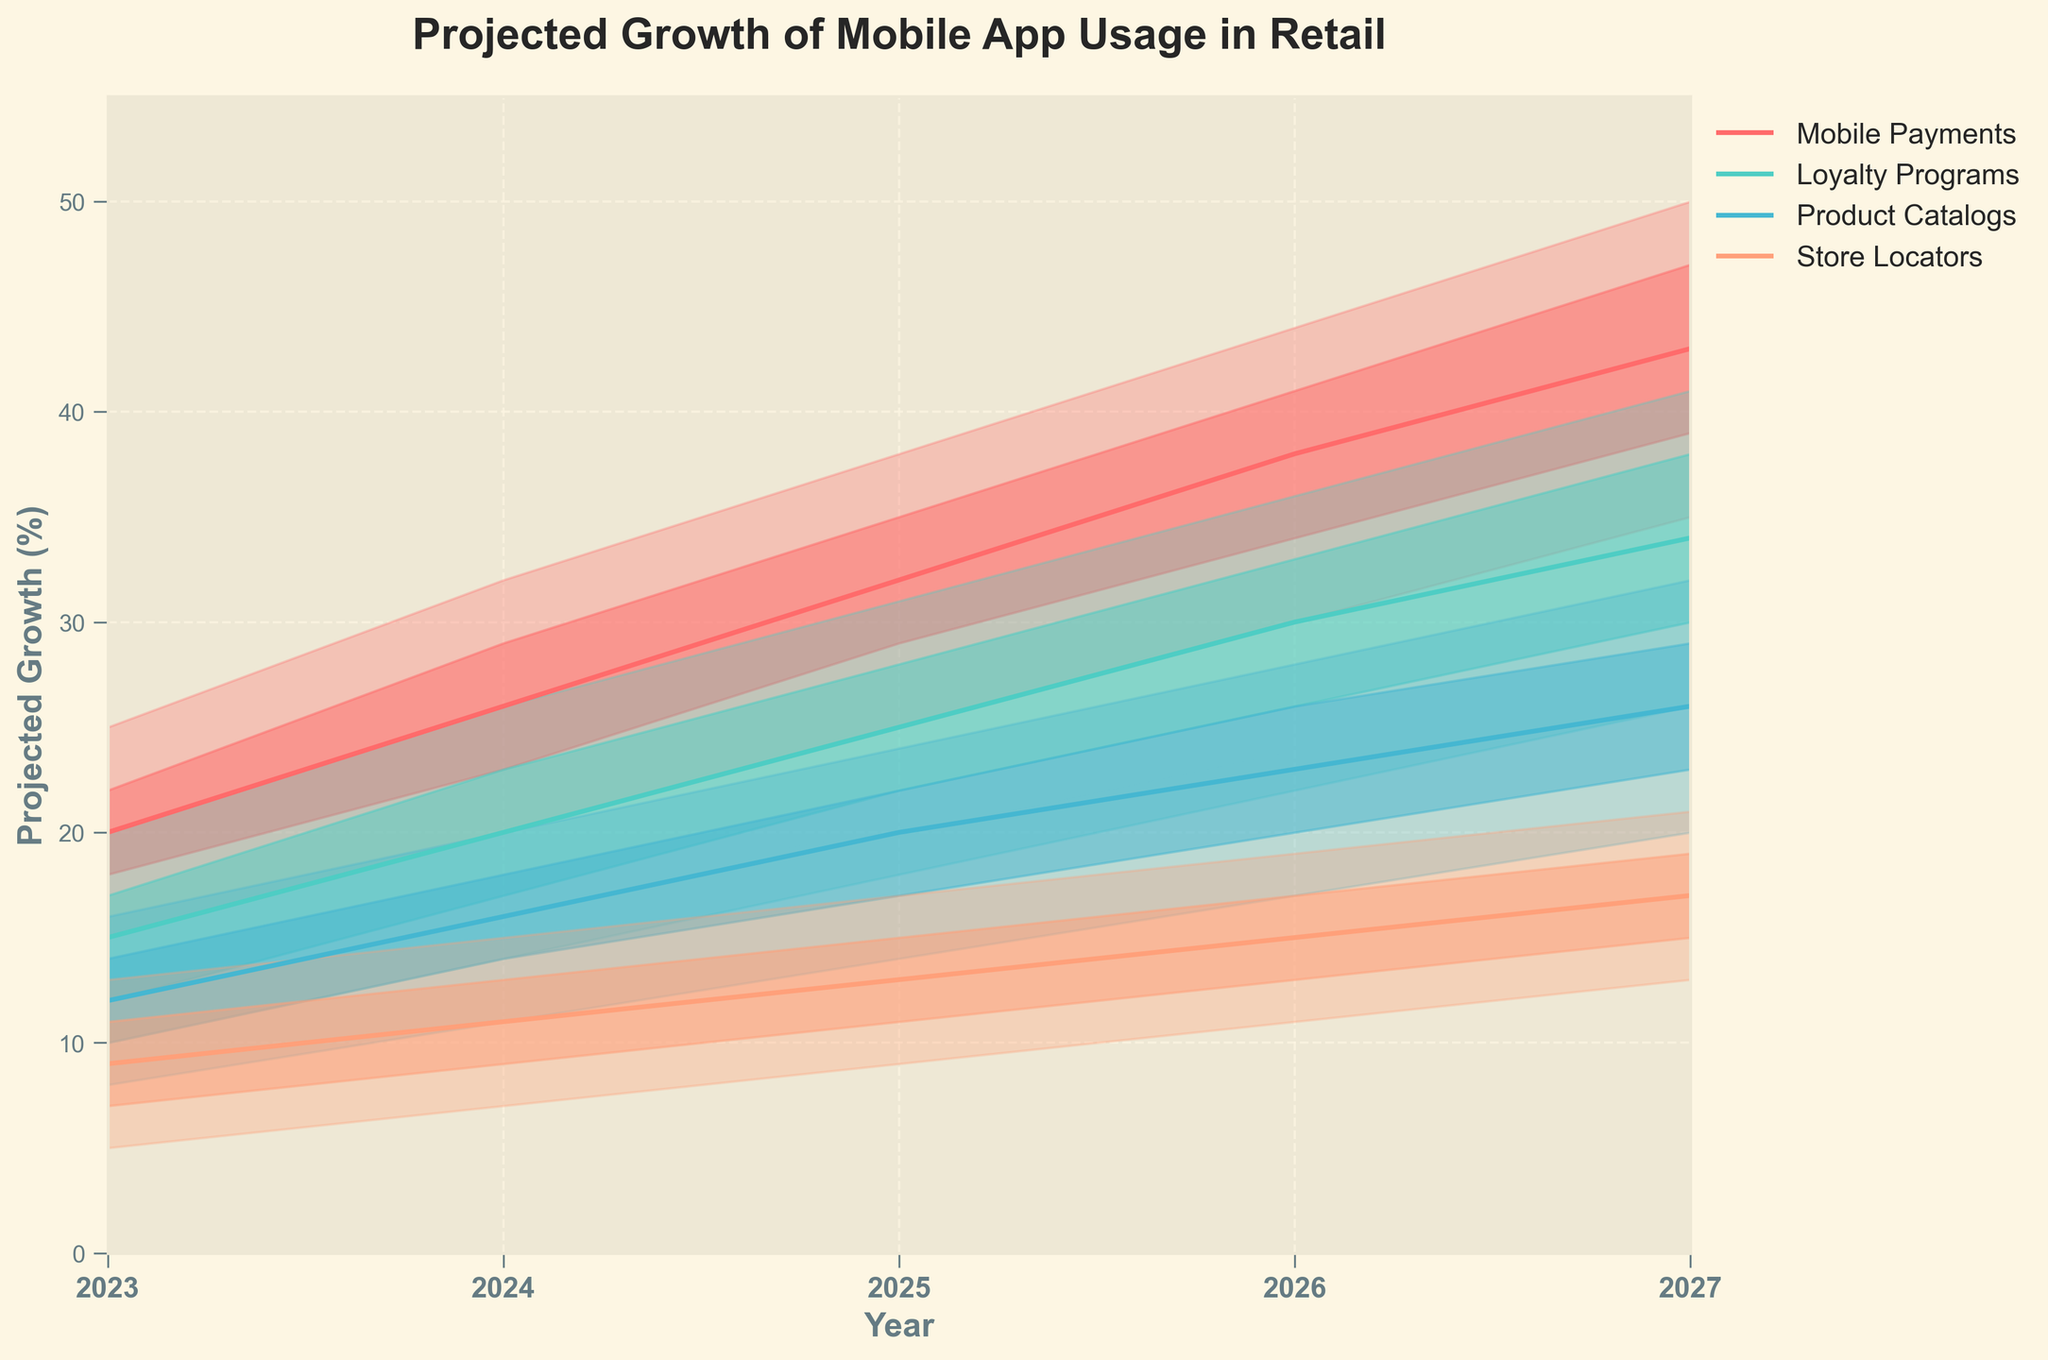What is the title of the figure? The title is usually located at the top of the figure. In this case, it reads "Projected Growth of Mobile App Usage in Retail".
Answer: Projected Growth of Mobile App Usage in Retail Which mobile app category has the highest projected growth in 2027? The highest value is found by checking the highest color bands in the 2027 section of the chart. Mobile Payments has the highest projection with a range of 35-50.
Answer: Mobile Payments How many years does the chart cover? The x-axis displays the years covered, starting from 2023 and ending in 2027. Counting these years gives us the total number.
Answer: 5 years What is the range of projected growth for Product Catalogs in 2025? Locate the Product Catalogs category in the 2025 section of the chart and check the range between the lowest and highest projections. The range is from 14 to 24.
Answer: 14-24 Which app category has the narrowest range of projected growth in 2024, and what is the range? Checking 2024 data for all categories, Store Locators has the narrowest range from 7 to 15.
Answer: Store Locators, 7-15 What is the median projected growth for Loyalty Programs in 2025? To find the median, locate Loyalty Programs for 2025 and check the middle value of the mid-range, which is 25.
Answer: 25 How does the maximum projected growth of Store Locators in 2027 compare to the minimum projected growth of Mobile Payments in the same year? Check the high band for Store Locators in 2027, which is 21, and the low band for Mobile Payments, which is 35. Comparatively, Store Locators' maximum is less than Mobile Payments' minimum.
Answer: Store Locators' max of 21 is less than Mobile Payments' min of 35 What is the average projected mid-range growth for Mobile Payments from 2023 to 2027? Add the mid-range values of Mobile Payments over the years (2023: 20, 2024: 26, 2025: 32, 2026: 38, 2027: 43). Then divide by the number of years (5). (20 + 26 + 32 + 38 + 43) / 5 = 31.8
Answer: 31.8 Between 2023 and 2027, which category shows the most consistent mid-range projected growth, and what range values support this? By analyzing the chart, Product Catalogs show the most consistent mid-range projections, varying by only ±3 each year (12, 16, 20, 23, 26).
Answer: Product Catalogs What trend can be observed in the projected growth of Loyalty Programs from 2023 to 2027? Reviewing the chart shows a clear increasing trend, with values starting at 12 in 2023 and rising to 34 by 2027 in the mid-range projections.
Answer: Increasing trend 